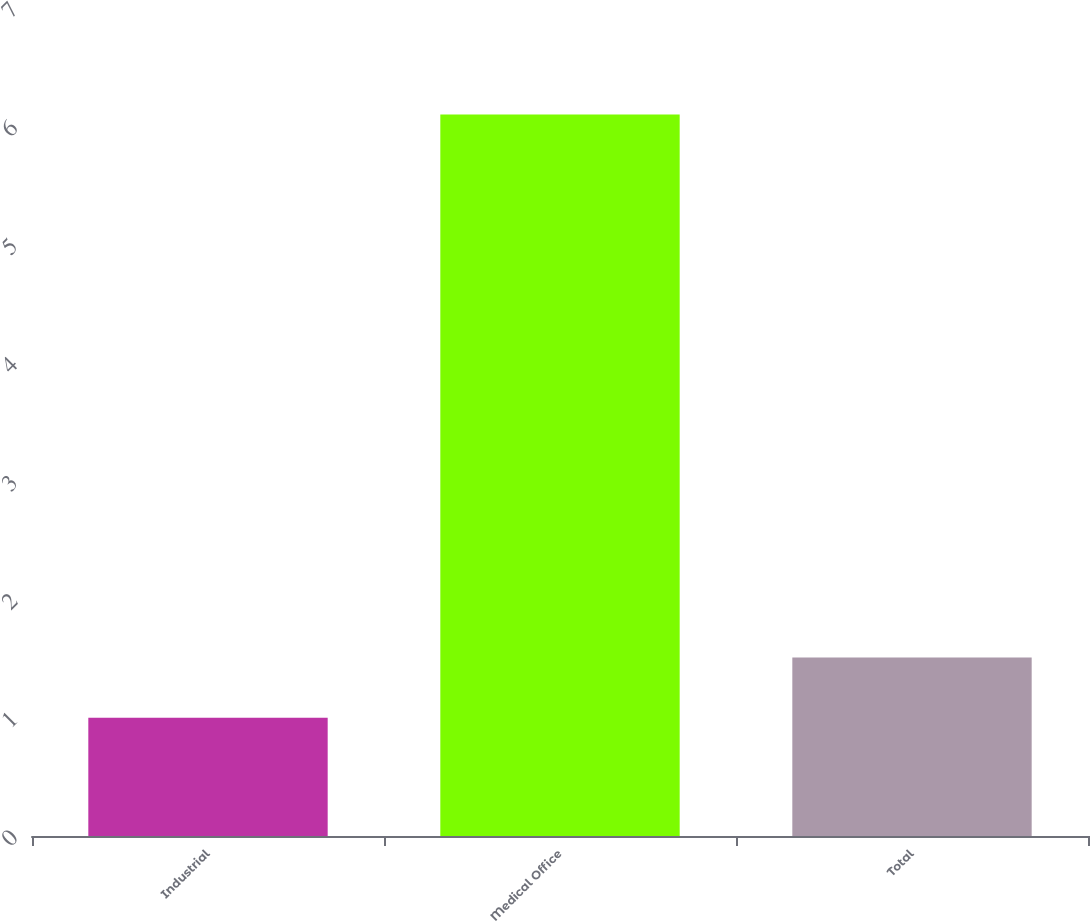Convert chart to OTSL. <chart><loc_0><loc_0><loc_500><loc_500><bar_chart><fcel>Industrial<fcel>Medical Office<fcel>Total<nl><fcel>1<fcel>6.1<fcel>1.51<nl></chart> 